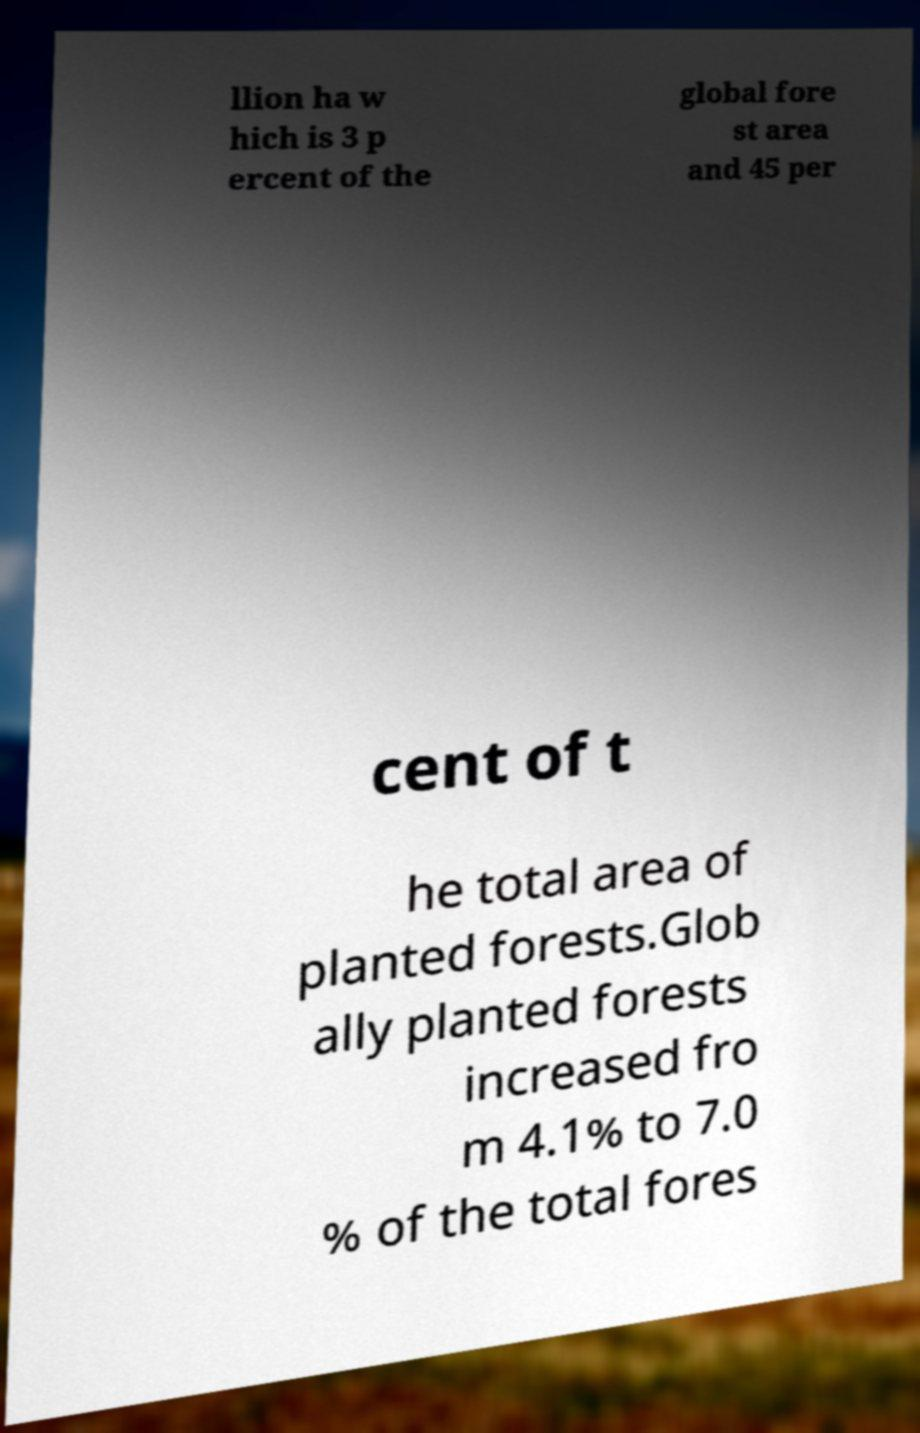Could you extract and type out the text from this image? llion ha w hich is 3 p ercent of the global fore st area and 45 per cent of t he total area of planted forests.Glob ally planted forests increased fro m 4.1% to 7.0 % of the total fores 